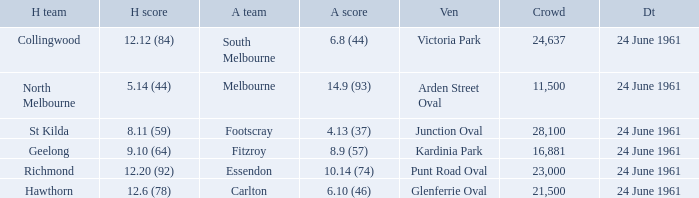What was the home team's score at the game attended by more than 24,637? 8.11 (59). 